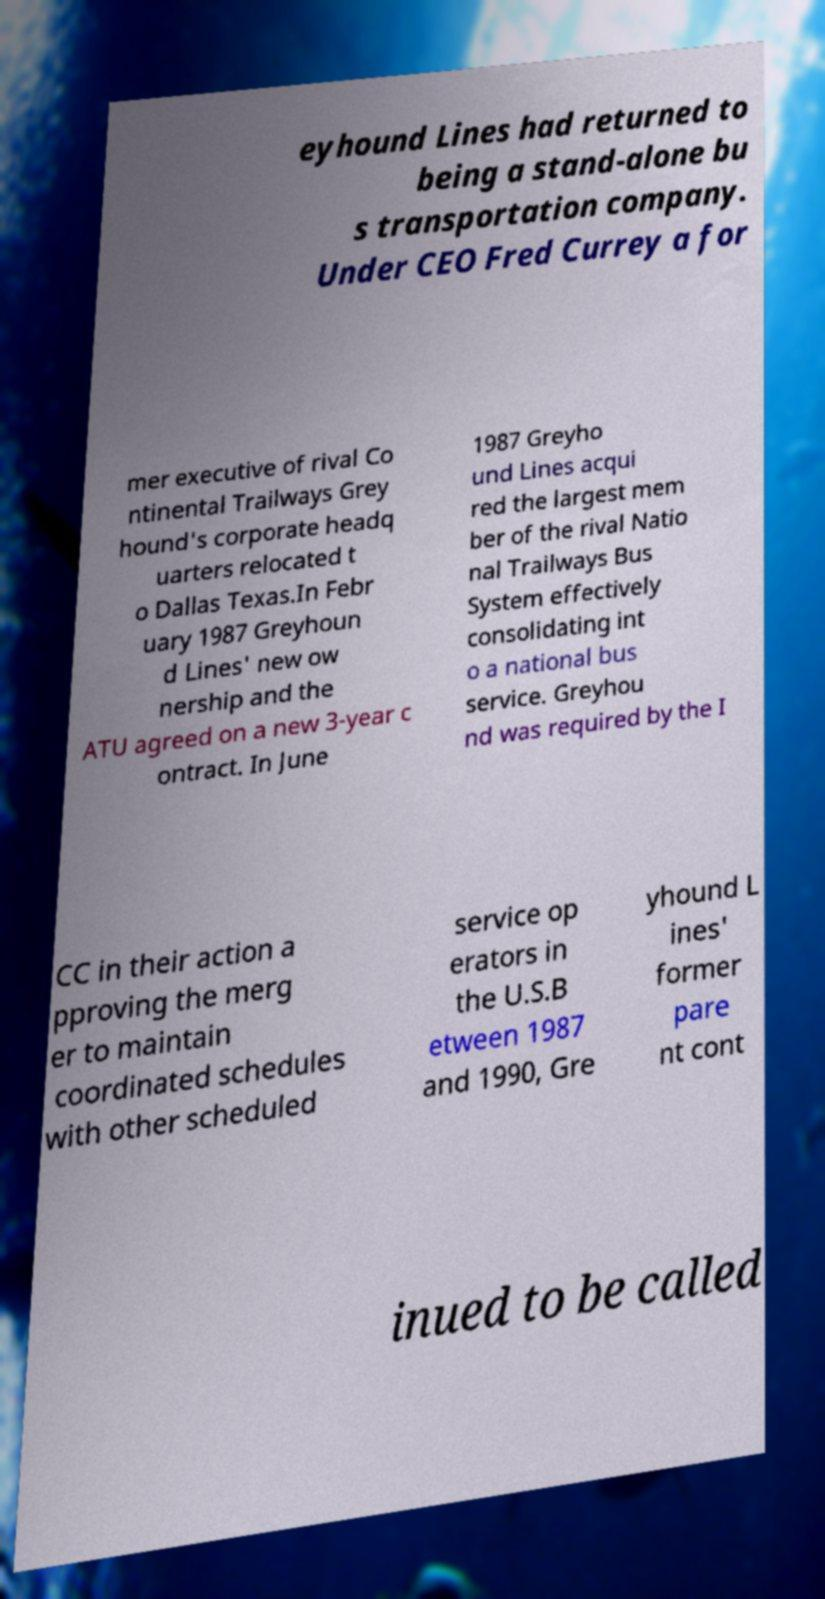I need the written content from this picture converted into text. Can you do that? eyhound Lines had returned to being a stand-alone bu s transportation company. Under CEO Fred Currey a for mer executive of rival Co ntinental Trailways Grey hound's corporate headq uarters relocated t o Dallas Texas.In Febr uary 1987 Greyhoun d Lines' new ow nership and the ATU agreed on a new 3-year c ontract. In June 1987 Greyho und Lines acqui red the largest mem ber of the rival Natio nal Trailways Bus System effectively consolidating int o a national bus service. Greyhou nd was required by the I CC in their action a pproving the merg er to maintain coordinated schedules with other scheduled service op erators in the U.S.B etween 1987 and 1990, Gre yhound L ines' former pare nt cont inued to be called 